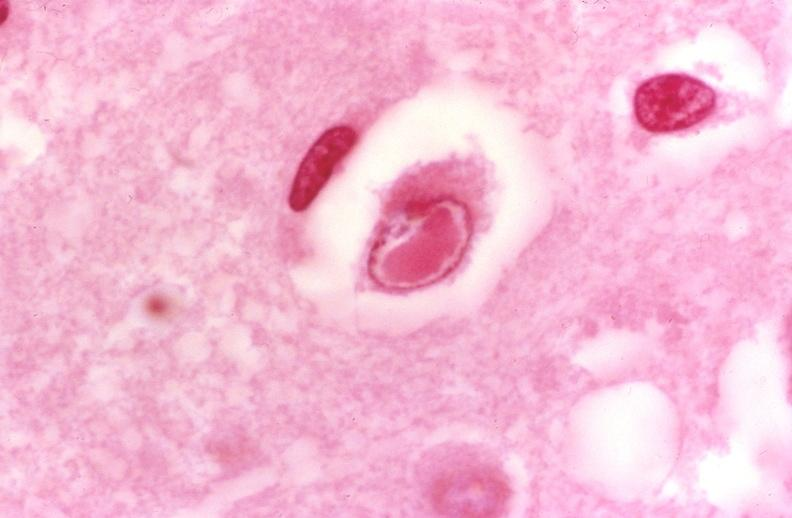does hematologic show brain, herpes inclusion bodies?
Answer the question using a single word or phrase. No 